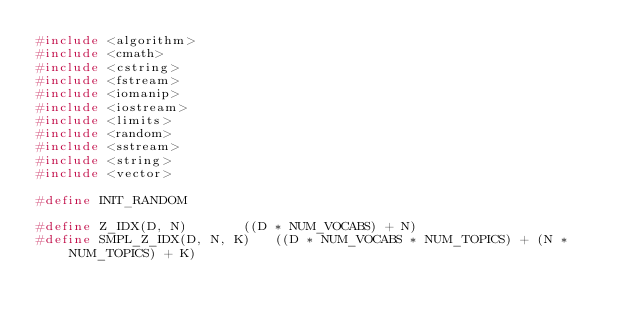<code> <loc_0><loc_0><loc_500><loc_500><_C++_>#include <algorithm>
#include <cmath>
#include <cstring>
#include <fstream>
#include <iomanip>
#include <iostream>
#include <limits>
#include <random>
#include <sstream>
#include <string>
#include <vector>

#define INIT_RANDOM

#define Z_IDX(D, N)				((D * NUM_VOCABS) + N)
#define SMPL_Z_IDX(D, N, K)		((D * NUM_VOCABS * NUM_TOPICS) + (N * NUM_TOPICS) + K)</code> 